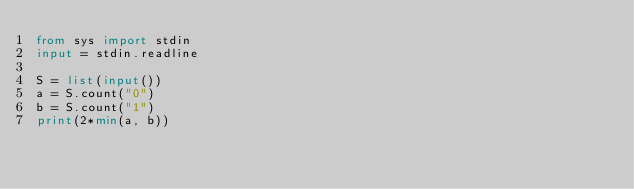<code> <loc_0><loc_0><loc_500><loc_500><_Python_>from sys import stdin
input = stdin.readline

S = list(input())
a = S.count("0")
b = S.count("1")
print(2*min(a, b))
</code> 